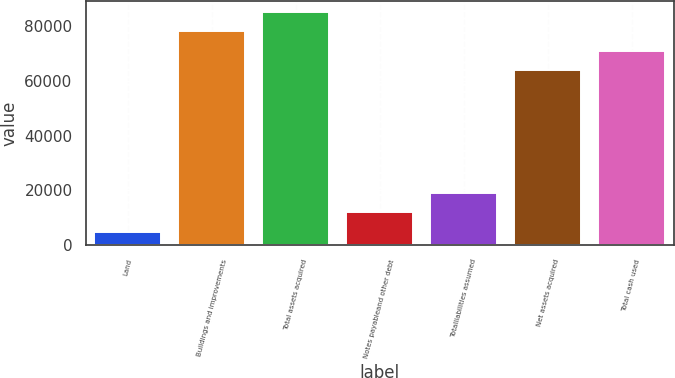Convert chart to OTSL. <chart><loc_0><loc_0><loc_500><loc_500><bar_chart><fcel>Land<fcel>Buildings and improvements<fcel>Total assets acquired<fcel>Notes payableand other debt<fcel>Totalliabilities assumed<fcel>Net assets acquired<fcel>Total cash used<nl><fcel>5016<fcel>77943.8<fcel>84926.2<fcel>11998.4<fcel>18980.8<fcel>63979<fcel>70961.4<nl></chart> 